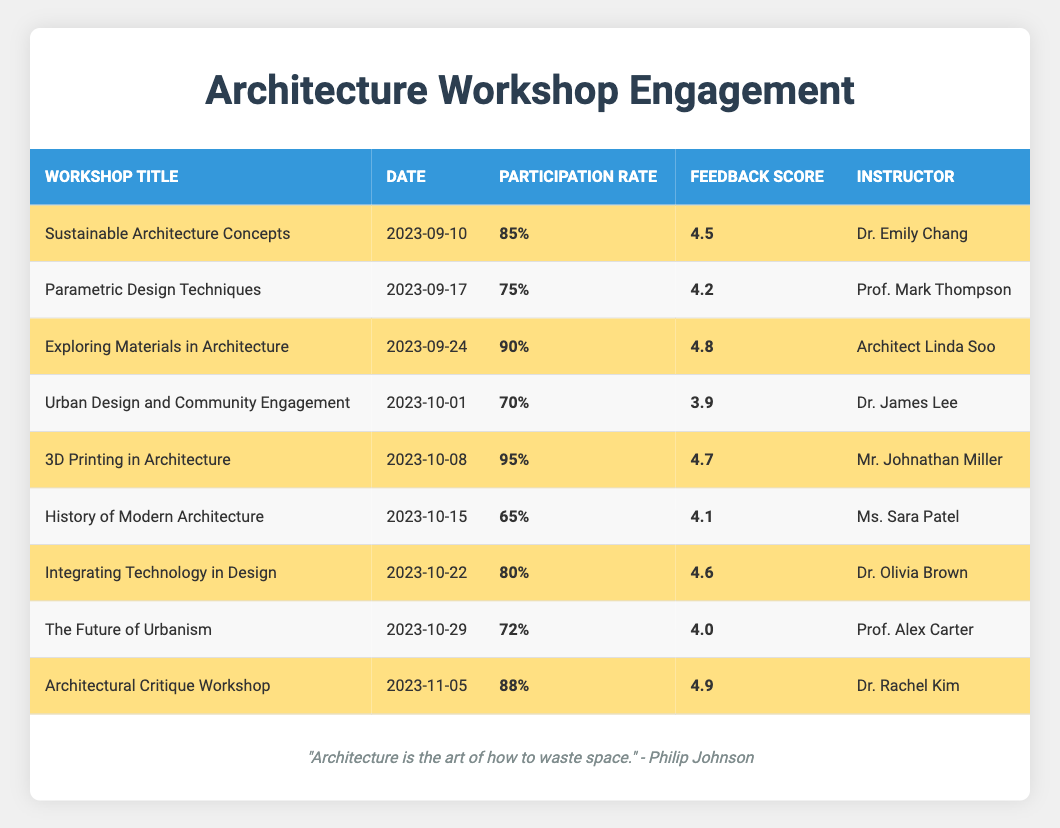What is the workshop with the highest participation rate? The participation rates are listed in the table, and the highest value is 95% for the workshop titled "3D Printing in Architecture."
Answer: 3D Printing in Architecture Which instructor received the highest student feedback score? The student feedback scores are reviewed, and the highest score is 4.9 from the workshop "Architectural Critique Workshop" by Dr. Rachel Kim.
Answer: Dr. Rachel Kim What is the average participation rate of all workshops? The participation rates are 85%, 75%, 90%, 70%, 95%, 65%, 80%, 72%, and 88%. Summing these values gives 85 + 75 + 90 + 70 + 95 + 65 + 80 + 72 + 88 = 825. There are 9 workshops, so the average is 825 / 9 = 91.67.
Answer: 91.67% Is the student feedback score for "Integrating Technology in Design" greater than 4.5? The feedback score for "Integrating Technology in Design" is 4.6, which is greater than 4.5.
Answer: Yes How many workshops had a participation rate of 80% or above? The workshops with rates of 80% or above are "Sustainable Architecture Concepts" (85%), "Exploring Materials in Architecture" (90%), "3D Printing in Architecture" (95%), "Integrating Technology in Design" (80%), and "Architectural Critique Workshop" (88%). This results in a total of 5 such workshops.
Answer: 5 What is the difference between the highest and lowest student feedback scores? The highest feedback score is 4.9 (Architectural Critique Workshop) and the lowest is 3.9 (Urban Design and Community Engagement). The difference is 4.9 - 3.9 = 1.0.
Answer: 1.0 What is the average feedback score for all workshops? The feedback scores are 4.5, 4.2, 4.8, 3.9, 4.7, 4.1, 4.6, 4.0, and 4.9. Summing these gives 4.5 + 4.2 + 4.8 + 3.9 + 4.7 + 4.1 + 4.6 + 4.0 + 4.9 = 38.7. There are 9 scores, so the average is 38.7 / 9 = 4.3.
Answer: 4.3 Which workshops had a participation rate below 80%? The workshops with participation rates below 80% are "Parametric Design Techniques" (75%), "Urban Design and Community Engagement" (70%), and "History of Modern Architecture" (65%). This totals 3 workshops.
Answer: 3 Did any workshop led by Dr. Emily Chang receive feedback below 4.5? Dr. Emily Chang taught "Sustainable Architecture Concepts," which received a feedback score of 4.5. This score is not below 4.5.
Answer: No 